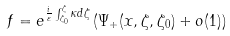Convert formula to latex. <formula><loc_0><loc_0><loc_500><loc_500>f = e ^ { \frac { i } { \varepsilon } \int _ { \zeta _ { 0 } } ^ { \zeta } \kappa d \zeta } \left ( \Psi _ { + } ( x , \zeta , \zeta _ { 0 } ) + o ( 1 ) \right )</formula> 